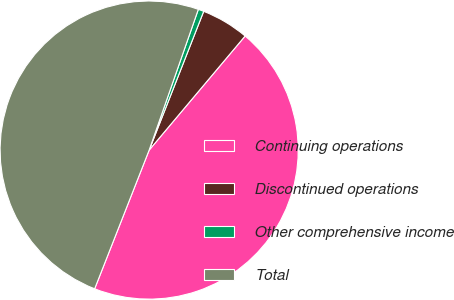<chart> <loc_0><loc_0><loc_500><loc_500><pie_chart><fcel>Continuing operations<fcel>Discontinued operations<fcel>Other comprehensive income<fcel>Total<nl><fcel>44.83%<fcel>5.17%<fcel>0.61%<fcel>49.39%<nl></chart> 